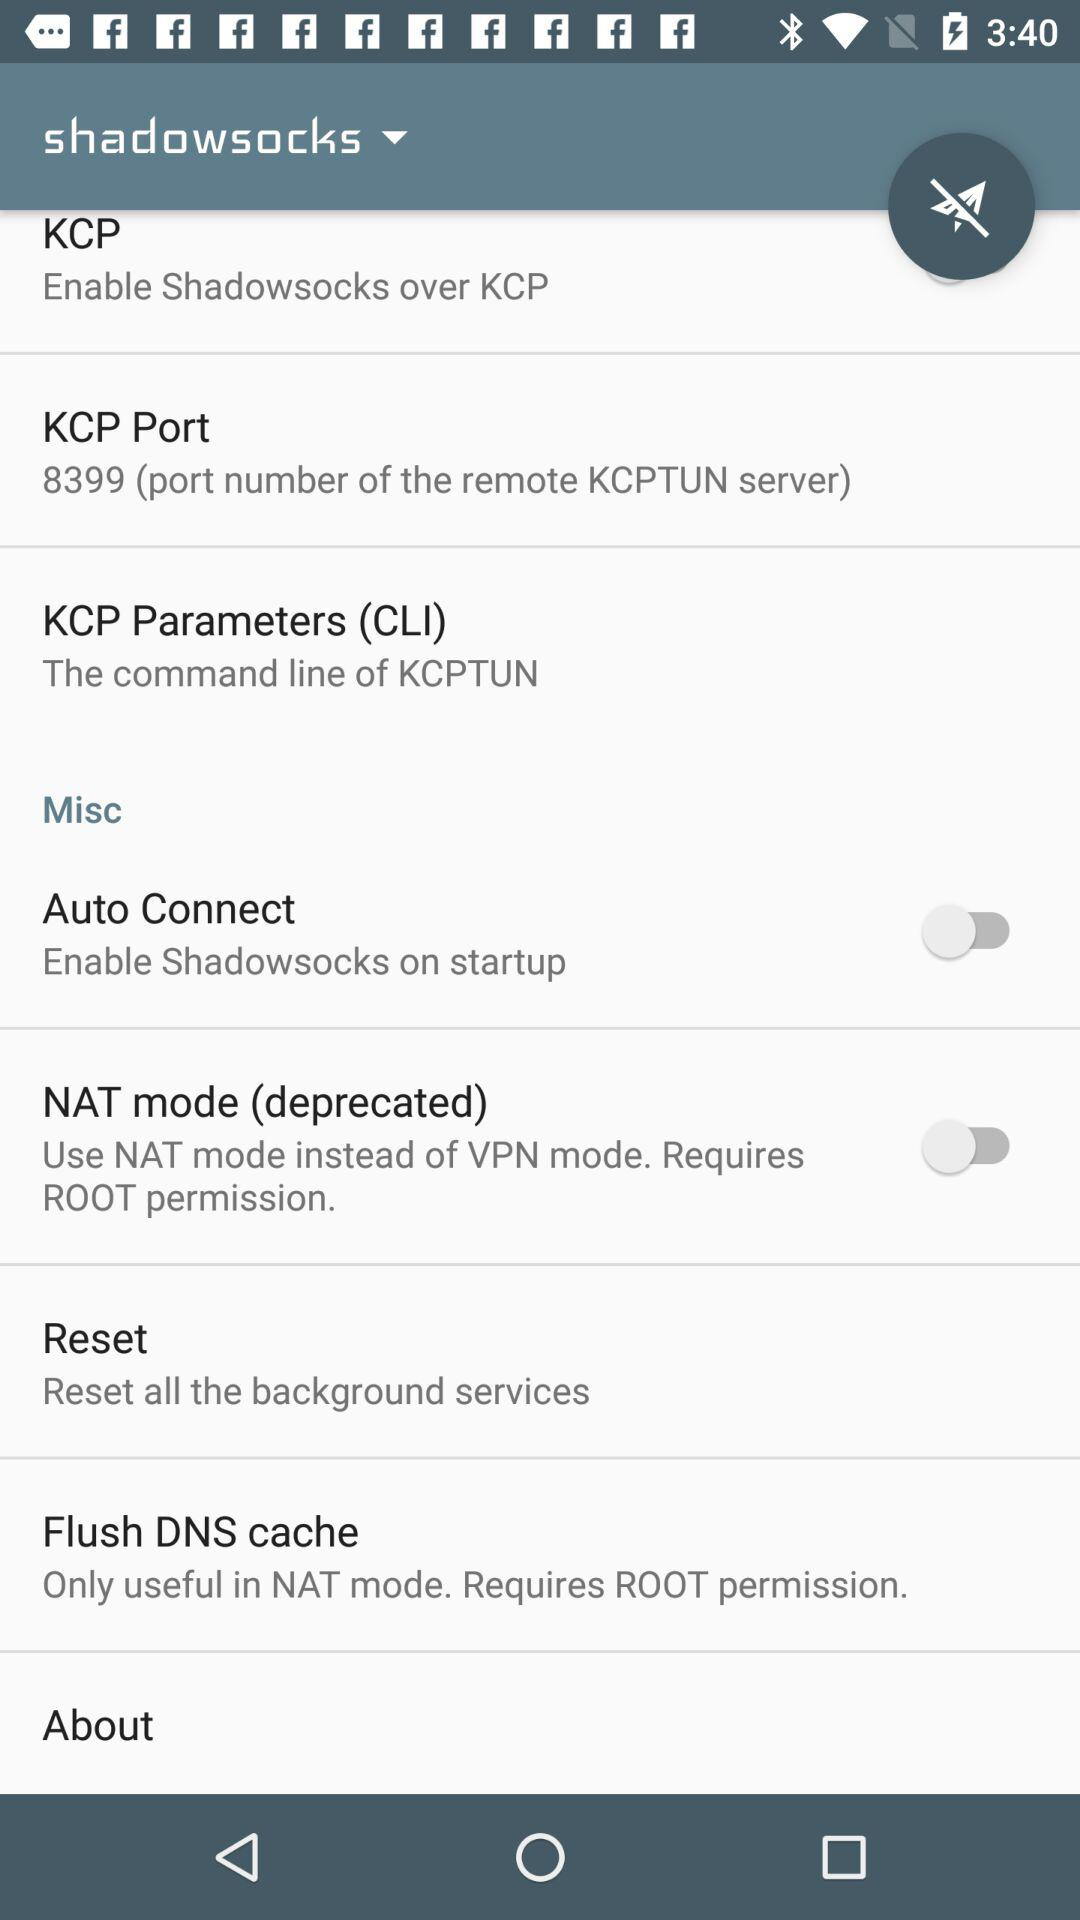What is the status of "Misc"?
When the provided information is insufficient, respond with <no answer>. <no answer> 